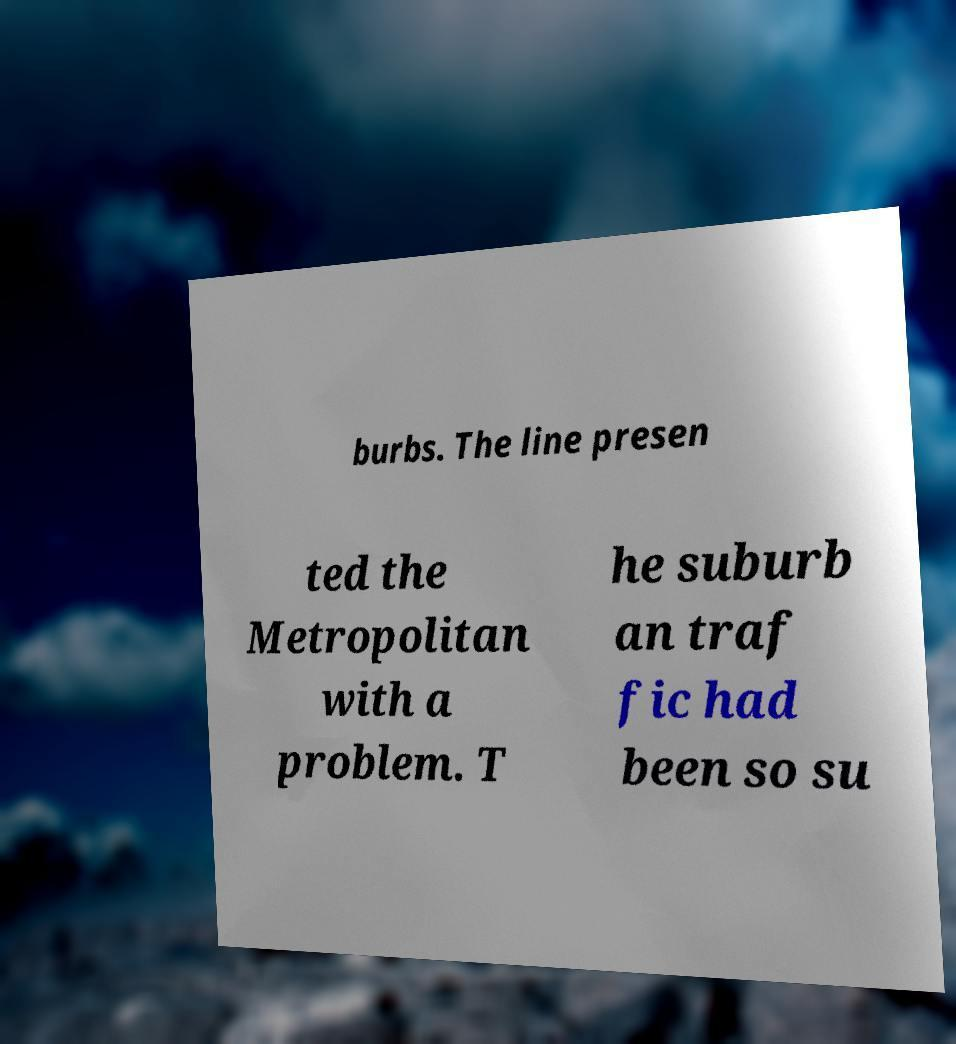What messages or text are displayed in this image? I need them in a readable, typed format. burbs. The line presen ted the Metropolitan with a problem. T he suburb an traf fic had been so su 